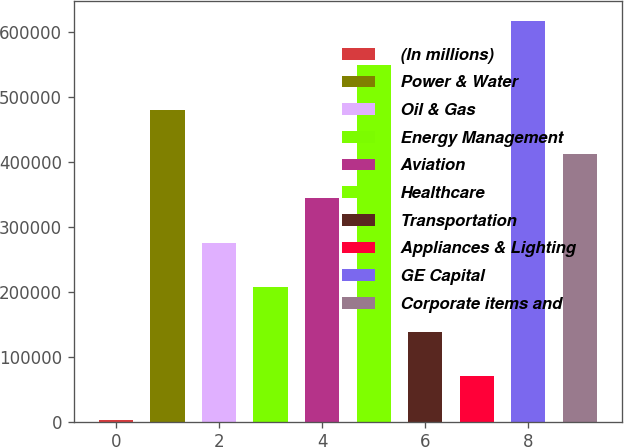<chart> <loc_0><loc_0><loc_500><loc_500><bar_chart><fcel>(In millions)<fcel>Power & Water<fcel>Oil & Gas<fcel>Energy Management<fcel>Aviation<fcel>Healthcare<fcel>Transportation<fcel>Appliances & Lighting<fcel>GE Capital<fcel>Corporate items and<nl><fcel>2012<fcel>480103<fcel>275207<fcel>206908<fcel>343506<fcel>548402<fcel>138609<fcel>70310.7<fcel>616700<fcel>411804<nl></chart> 